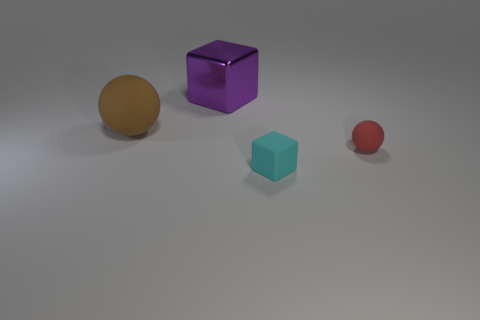What color is the shiny object?
Your response must be concise. Purple. There is a rubber thing right of the cyan matte object; how big is it?
Ensure brevity in your answer.  Small. There is a small rubber thing that is behind the tiny thing that is to the left of the red ball; how many brown spheres are to the left of it?
Keep it short and to the point. 1. There is a small matte thing behind the tiny matte object on the left side of the tiny rubber ball; what color is it?
Give a very brief answer. Red. Are there any other cubes that have the same size as the purple cube?
Your response must be concise. No. There is a thing that is in front of the ball that is to the right of the cube in front of the small red ball; what is its material?
Make the answer very short. Rubber. What number of small cubes are in front of the block in front of the big cube?
Make the answer very short. 0. There is a block in front of the purple block; is it the same size as the large block?
Your response must be concise. No. What number of small red matte objects are the same shape as the purple thing?
Offer a very short reply. 0. What shape is the tiny cyan rubber thing?
Ensure brevity in your answer.  Cube. 